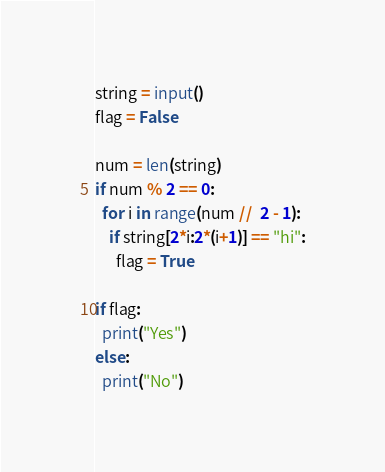Convert code to text. <code><loc_0><loc_0><loc_500><loc_500><_Python_>string = input()
flag = False

num = len(string)
if num % 2 == 0:
  for i in range(num //  2 - 1):
    if string[2*i:2*(i+1)] == "hi":
      flag = True

if flag:
  print("Yes")
else:
  print("No")</code> 